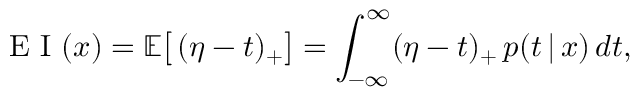<formula> <loc_0><loc_0><loc_500><loc_500>E I ( x ) = \mathbb { E } \left [ \, ( \eta - t ) _ { + } \right ] = \int _ { - \infty } ^ { \infty } ( \eta - t ) _ { + } \, p ( t \, | \, x ) \, d t ,</formula> 